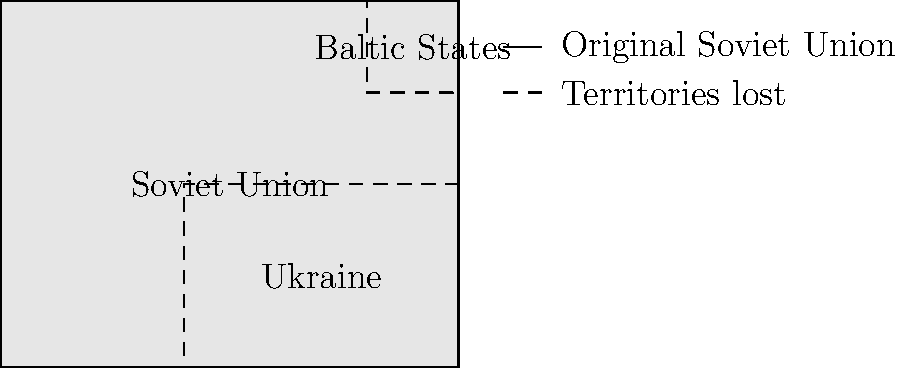Which of the following regions, as shown in the map, was the last to gain independence from the Soviet Union, leading to its final dissolution in 1991?
A) Baltic States
B) Ukraine
C) Kazakhstan (not shown)
D) Belarus (not shown) To answer this question, we need to consider the chronological order of events leading to the dissolution of the Soviet Union:

1. The Baltic States (Estonia, Latvia, and Lithuania) were the first to declare independence in 1990 and had it recognized by September 1991.

2. Ukraine declared independence on August 24, 1991, following the failed August Coup in Moscow.

3. Belarus declared independence on August 25, 1991.

4. Kazakhstan was the last Soviet republic to declare independence on December 16, 1991.

5. The Soviet Union officially ceased to exist on December 26, 1991, when the Russian SFSR renamed itself as the Russian Federation and effectively succeeded the Soviet Union.

Although Kazakhstan is not shown on the map, it is the correct answer as it was the last republic to declare independence, which directly led to the final dissolution of the Soviet Union.
Answer: Kazakhstan 